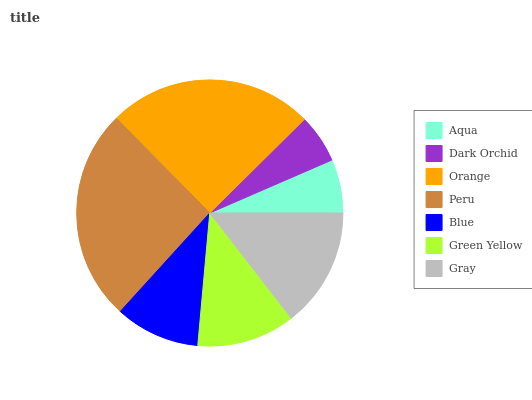Is Dark Orchid the minimum?
Answer yes or no. Yes. Is Peru the maximum?
Answer yes or no. Yes. Is Orange the minimum?
Answer yes or no. No. Is Orange the maximum?
Answer yes or no. No. Is Orange greater than Dark Orchid?
Answer yes or no. Yes. Is Dark Orchid less than Orange?
Answer yes or no. Yes. Is Dark Orchid greater than Orange?
Answer yes or no. No. Is Orange less than Dark Orchid?
Answer yes or no. No. Is Green Yellow the high median?
Answer yes or no. Yes. Is Green Yellow the low median?
Answer yes or no. Yes. Is Blue the high median?
Answer yes or no. No. Is Gray the low median?
Answer yes or no. No. 